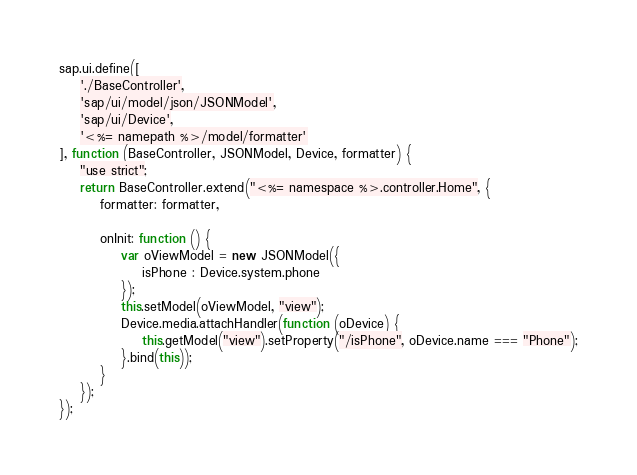Convert code to text. <code><loc_0><loc_0><loc_500><loc_500><_JavaScript_>sap.ui.define([
	'./BaseController',
	'sap/ui/model/json/JSONModel',
	'sap/ui/Device',
	'<%= namepath %>/model/formatter'
], function (BaseController, JSONModel, Device, formatter) {
	"use strict";
	return BaseController.extend("<%= namespace %>.controller.Home", {
		formatter: formatter,

		onInit: function () {
			var oViewModel = new JSONModel({
				isPhone : Device.system.phone
			});
			this.setModel(oViewModel, "view");
			Device.media.attachHandler(function (oDevice) {
				this.getModel("view").setProperty("/isPhone", oDevice.name === "Phone");
			}.bind(this));
		}
	});
});</code> 